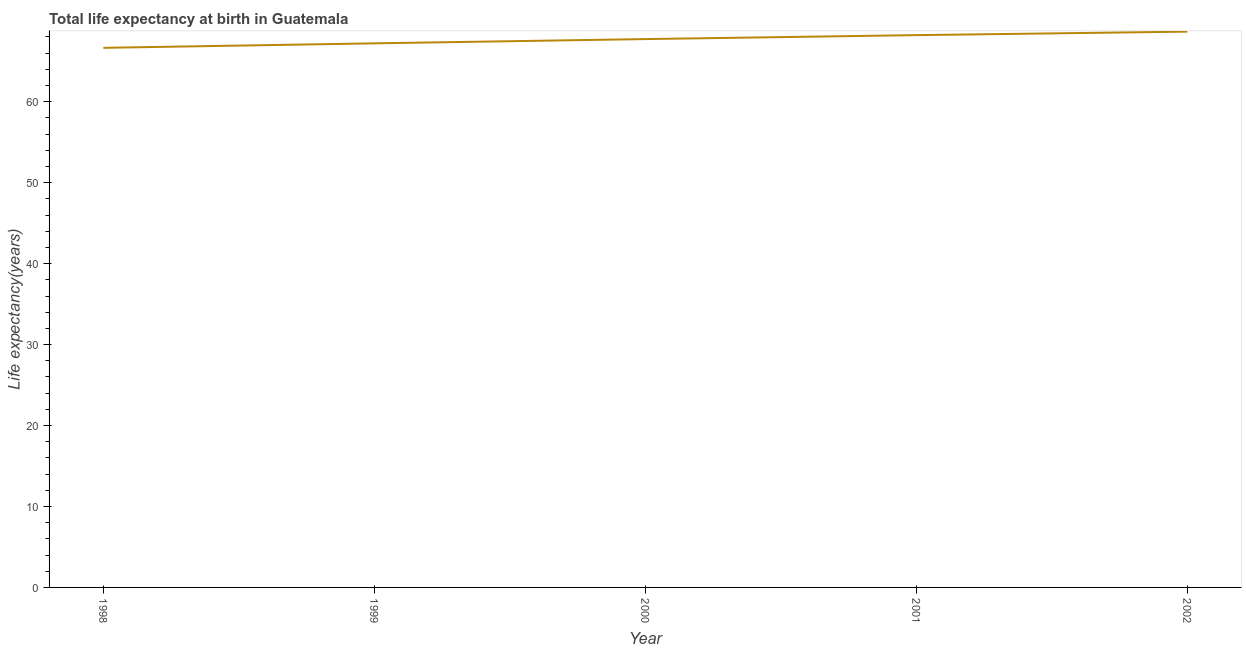What is the life expectancy at birth in 1999?
Your answer should be very brief. 67.22. Across all years, what is the maximum life expectancy at birth?
Provide a succinct answer. 68.66. Across all years, what is the minimum life expectancy at birth?
Make the answer very short. 66.66. What is the sum of the life expectancy at birth?
Your answer should be very brief. 338.51. What is the difference between the life expectancy at birth in 1998 and 2002?
Offer a very short reply. -2. What is the average life expectancy at birth per year?
Make the answer very short. 67.7. What is the median life expectancy at birth?
Your answer should be very brief. 67.74. What is the ratio of the life expectancy at birth in 1998 to that in 2001?
Offer a terse response. 0.98. Is the life expectancy at birth in 1998 less than that in 1999?
Offer a very short reply. Yes. Is the difference between the life expectancy at birth in 2000 and 2002 greater than the difference between any two years?
Ensure brevity in your answer.  No. What is the difference between the highest and the second highest life expectancy at birth?
Ensure brevity in your answer.  0.43. What is the difference between the highest and the lowest life expectancy at birth?
Provide a short and direct response. 2. How many lines are there?
Give a very brief answer. 1. How many years are there in the graph?
Provide a succinct answer. 5. What is the title of the graph?
Provide a succinct answer. Total life expectancy at birth in Guatemala. What is the label or title of the Y-axis?
Provide a succinct answer. Life expectancy(years). What is the Life expectancy(years) in 1998?
Your answer should be compact. 66.66. What is the Life expectancy(years) of 1999?
Offer a very short reply. 67.22. What is the Life expectancy(years) in 2000?
Your answer should be very brief. 67.74. What is the Life expectancy(years) of 2001?
Your answer should be very brief. 68.23. What is the Life expectancy(years) in 2002?
Offer a very short reply. 68.66. What is the difference between the Life expectancy(years) in 1998 and 1999?
Keep it short and to the point. -0.55. What is the difference between the Life expectancy(years) in 1998 and 2000?
Keep it short and to the point. -1.08. What is the difference between the Life expectancy(years) in 1998 and 2001?
Ensure brevity in your answer.  -1.57. What is the difference between the Life expectancy(years) in 1998 and 2002?
Offer a terse response. -2. What is the difference between the Life expectancy(years) in 1999 and 2000?
Keep it short and to the point. -0.53. What is the difference between the Life expectancy(years) in 1999 and 2001?
Give a very brief answer. -1.01. What is the difference between the Life expectancy(years) in 1999 and 2002?
Provide a short and direct response. -1.45. What is the difference between the Life expectancy(years) in 2000 and 2001?
Provide a succinct answer. -0.48. What is the difference between the Life expectancy(years) in 2000 and 2002?
Your answer should be compact. -0.92. What is the difference between the Life expectancy(years) in 2001 and 2002?
Provide a short and direct response. -0.43. What is the ratio of the Life expectancy(years) in 1998 to that in 2002?
Give a very brief answer. 0.97. What is the ratio of the Life expectancy(years) in 1999 to that in 2001?
Make the answer very short. 0.98. What is the ratio of the Life expectancy(years) in 2000 to that in 2001?
Your response must be concise. 0.99. 